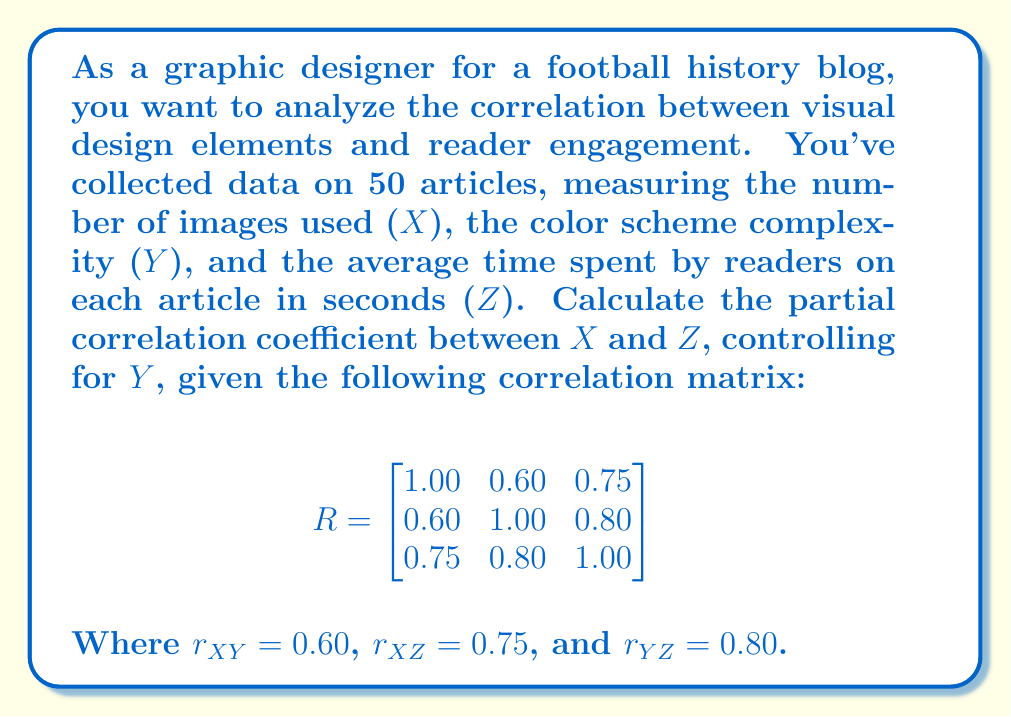Teach me how to tackle this problem. To calculate the partial correlation coefficient between X and Z, controlling for Y, we'll use the formula:

$$r_{XZ.Y} = \frac{r_{XZ} - r_{XY}r_{YZ}}{\sqrt{(1-r_{XY}^2)(1-r_{YZ}^2)}}$$

Where:
$r_{XZ.Y}$ is the partial correlation coefficient
$r_{XZ}$ is the correlation between X and Z
$r_{XY}$ is the correlation between X and Y
$r_{YZ}$ is the correlation between Y and Z

Step 1: Substitute the given values into the formula.
$$r_{XZ.Y} = \frac{0.75 - (0.60)(0.80)}{\sqrt{(1-0.60^2)(1-0.80^2)}}$$

Step 2: Calculate the numerator.
$$0.75 - (0.60)(0.80) = 0.75 - 0.48 = 0.27$$

Step 3: Calculate the denominator.
$$\sqrt{(1-0.60^2)(1-0.80^2)} = \sqrt{(1-0.36)(1-0.64)} = \sqrt{(0.64)(0.36)} = \sqrt{0.2304} = 0.48$$

Step 4: Divide the numerator by the denominator.
$$r_{XZ.Y} = \frac{0.27}{0.48} = 0.5625$$

Therefore, the partial correlation coefficient between X (number of images) and Z (average time spent), controlling for Y (color scheme complexity), is approximately 0.5625.
Answer: $r_{XZ.Y} \approx 0.5625$ 